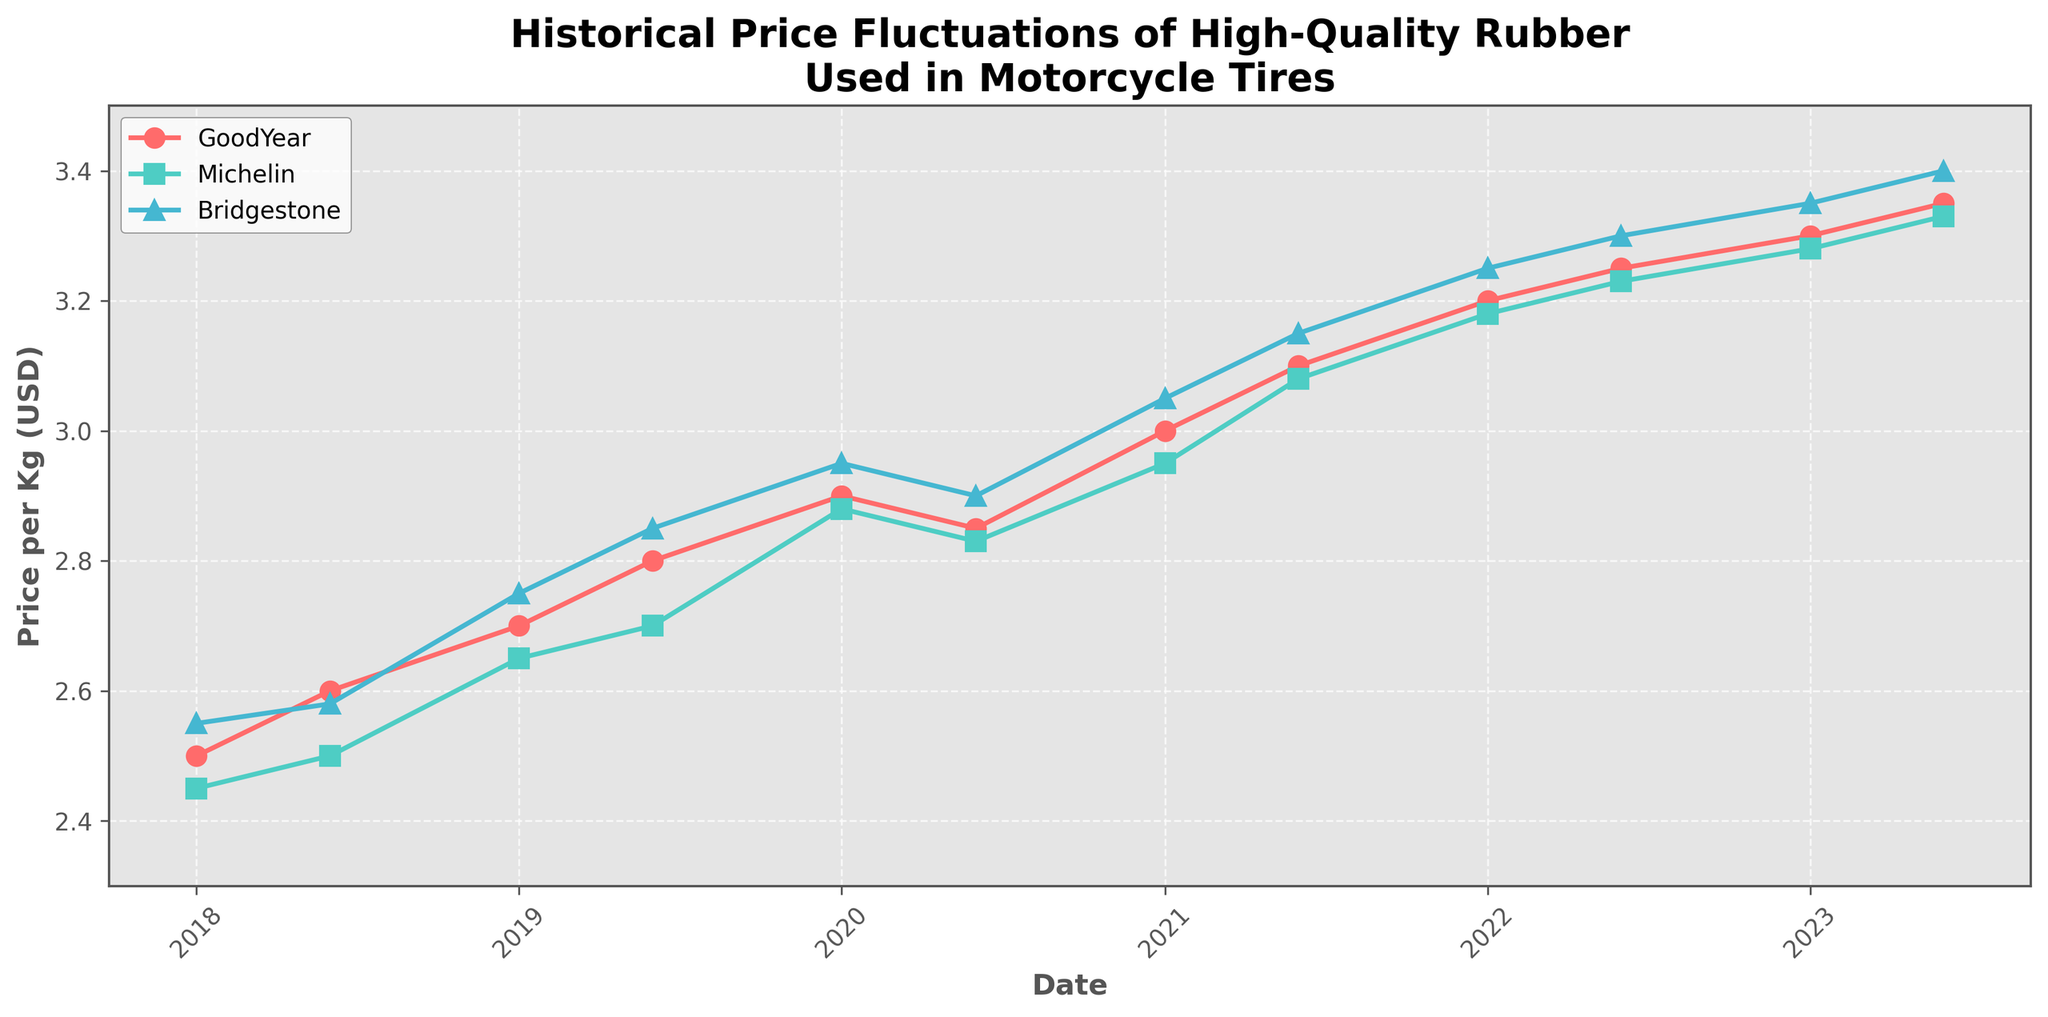What is the title of the plot? The title of the plot is usually shown at the top center of the figure. Here, it says "Historical Price Fluctuations of High-Quality Rubber Used in Motorcycle Tires".
Answer: Historical Price Fluctuations of High-Quality Rubber Used in Motorcycle Tires Which company had the highest price per kg in the latest date shown? To answer this, we look at the prices for the date 2023-06-01. GoodYear is $3.35, Michelin is $3.33, and Bridgestone is $3.40. Thus, Bridgestone had the highest price.
Answer: Bridgestone What is the average price of rubber per kg across all companies on 2022-01-01? On 2022-01-01, the prices are GoodYear: $3.20, Michelin: $3.18, Bridgestone: $3.25. The average is calculated as (3.20 + 3.18 + 3.25) / 3.
Answer: 3.21 How did the price of Michelin's rubber change from 2020-01-01 to 2020-06-01? On 2020-01-01, Michelin's price is $2.88, and on 2020-06-01, it is $2.83. The change is $2.83 - $2.88, which is a decrease of $0.05.
Answer: Decreased by $0.05 Which company shows a consistent increase in rubber prices from 2019 to 2023 without any declines? By examining the trend lines, we notice that all companies have slight declines at certain points, except for GoodYear, which shows steady increases.
Answer: GoodYear What was the price per kg of Bridgestone rubber on 2018-06-01? To find this, we refer directly to the data point on 2018-06-01 for Bridgestone, which shows $2.58 per kg.
Answer: $2.58 Between June 2022 and June 2023, which company's price increased the most? By comparing June 2022 to June 2023, we calculate the increases: GoodYear $3.35 - $3.25 = $0.10, Michelin $3.33 - $3.23 = $0.10, Bridgestone $3.40 - $3.30 = $0.10. All show the same increase.
Answer: All increased the same amount What is the price trend for Goodyear between 2018 and 2023? Looking at the plot, Goodyear's prices consistently increase from 2018 ($2.50) to 2023 ($3.35) without any drops except a minor decline in 2020.
Answer: Mostly increasing Which date shows the lowest price for Michelin rubber? By checking all the data points for Michelin, the lowest price is $2.45 on 2018-01-01.
Answer: 2018-01-01 From 2021-06-01 to 2023-06-01, what is the overall price increase for Bridgestone? Bridgestone's price on 2021-06-01 was $3.15, and on 2023-06-01 it was $3.40. The increase is $3.40 - $3.15.
Answer: $0.25 